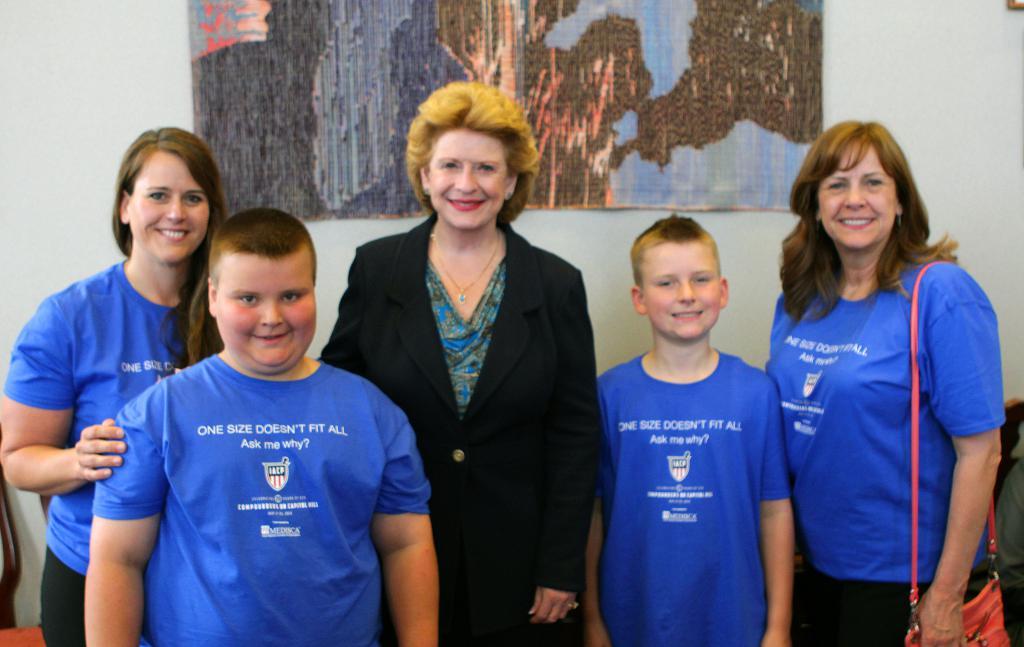What does the first line on the blue t-shirts say?
Offer a very short reply. One size doesn't fit all. 